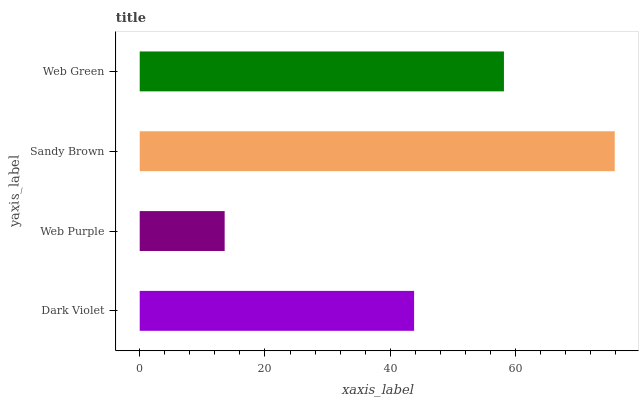Is Web Purple the minimum?
Answer yes or no. Yes. Is Sandy Brown the maximum?
Answer yes or no. Yes. Is Sandy Brown the minimum?
Answer yes or no. No. Is Web Purple the maximum?
Answer yes or no. No. Is Sandy Brown greater than Web Purple?
Answer yes or no. Yes. Is Web Purple less than Sandy Brown?
Answer yes or no. Yes. Is Web Purple greater than Sandy Brown?
Answer yes or no. No. Is Sandy Brown less than Web Purple?
Answer yes or no. No. Is Web Green the high median?
Answer yes or no. Yes. Is Dark Violet the low median?
Answer yes or no. Yes. Is Dark Violet the high median?
Answer yes or no. No. Is Web Purple the low median?
Answer yes or no. No. 